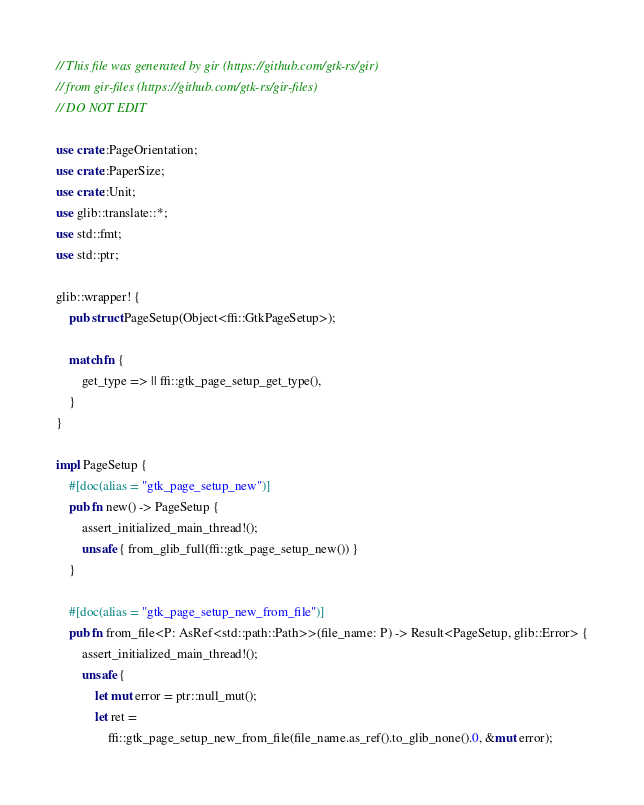<code> <loc_0><loc_0><loc_500><loc_500><_Rust_>// This file was generated by gir (https://github.com/gtk-rs/gir)
// from gir-files (https://github.com/gtk-rs/gir-files)
// DO NOT EDIT

use crate::PageOrientation;
use crate::PaperSize;
use crate::Unit;
use glib::translate::*;
use std::fmt;
use std::ptr;

glib::wrapper! {
    pub struct PageSetup(Object<ffi::GtkPageSetup>);

    match fn {
        get_type => || ffi::gtk_page_setup_get_type(),
    }
}

impl PageSetup {
    #[doc(alias = "gtk_page_setup_new")]
    pub fn new() -> PageSetup {
        assert_initialized_main_thread!();
        unsafe { from_glib_full(ffi::gtk_page_setup_new()) }
    }

    #[doc(alias = "gtk_page_setup_new_from_file")]
    pub fn from_file<P: AsRef<std::path::Path>>(file_name: P) -> Result<PageSetup, glib::Error> {
        assert_initialized_main_thread!();
        unsafe {
            let mut error = ptr::null_mut();
            let ret =
                ffi::gtk_page_setup_new_from_file(file_name.as_ref().to_glib_none().0, &mut error);</code> 